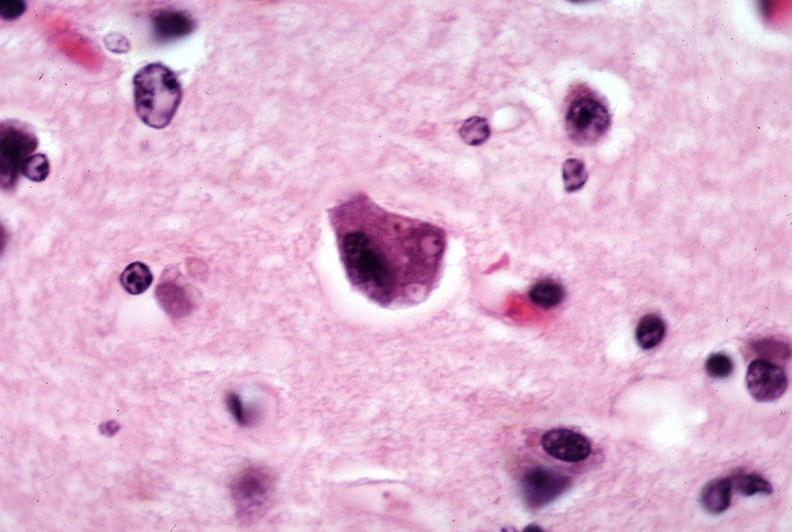does case of dic not bad photo show brain, pick 's disease?
Answer the question using a single word or phrase. No 